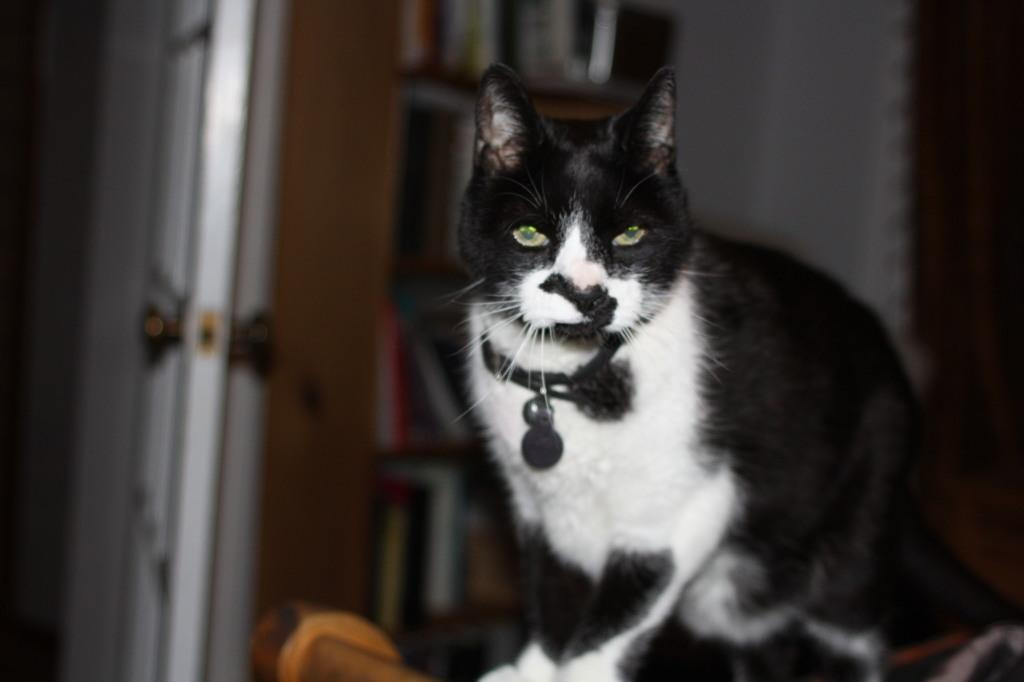What type of animal is in the image? There is a cat in the image. How would you describe the background of the image? The background appears blurry. What can be seen in the background of the image? There is a cupboard in the background. What is on the cupboard in the image? There are books on the cupboard. What type of jelly is being cooked by the cat in the image? There is no jelly or cooking activity present in the image; it features a cat and a blurry background with a cupboard and books. 